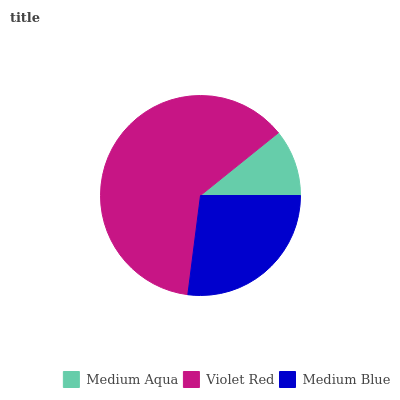Is Medium Aqua the minimum?
Answer yes or no. Yes. Is Violet Red the maximum?
Answer yes or no. Yes. Is Medium Blue the minimum?
Answer yes or no. No. Is Medium Blue the maximum?
Answer yes or no. No. Is Violet Red greater than Medium Blue?
Answer yes or no. Yes. Is Medium Blue less than Violet Red?
Answer yes or no. Yes. Is Medium Blue greater than Violet Red?
Answer yes or no. No. Is Violet Red less than Medium Blue?
Answer yes or no. No. Is Medium Blue the high median?
Answer yes or no. Yes. Is Medium Blue the low median?
Answer yes or no. Yes. Is Medium Aqua the high median?
Answer yes or no. No. Is Violet Red the low median?
Answer yes or no. No. 